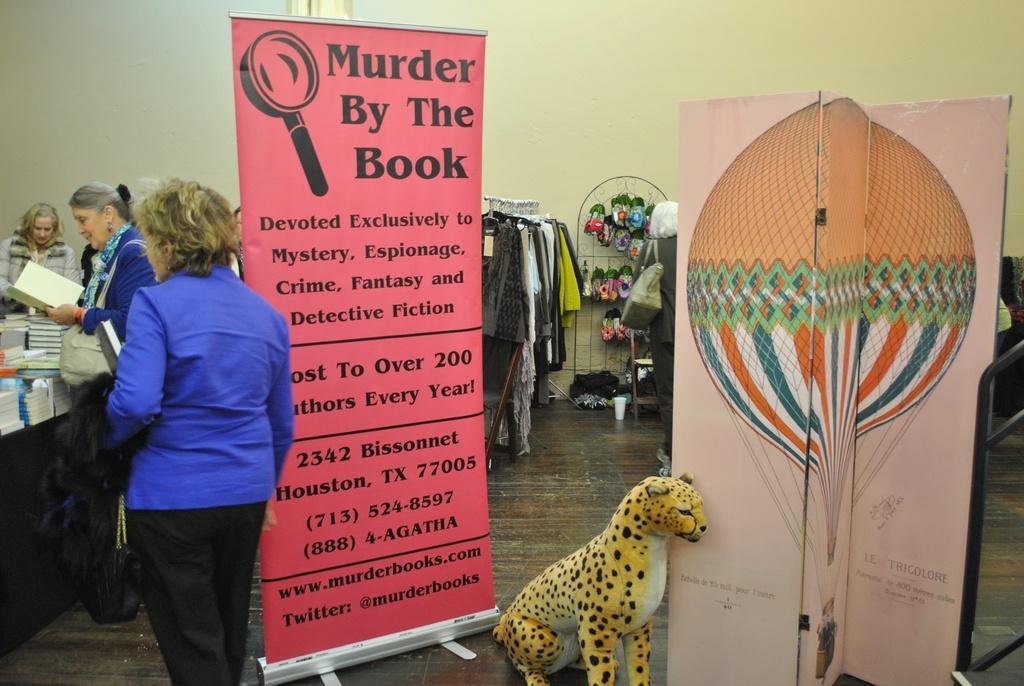Could you give a brief overview of what you see in this image? There are women and we can see banners and toy animal on the floor. We can see books on the table. In the background we can see clothes, objects on stand, wall and glass. 